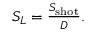Convert formula to latex. <formula><loc_0><loc_0><loc_500><loc_500>\begin{array} { r } { S _ { L } = \frac { S _ { s h o t } } { D } . } \end{array}</formula> 